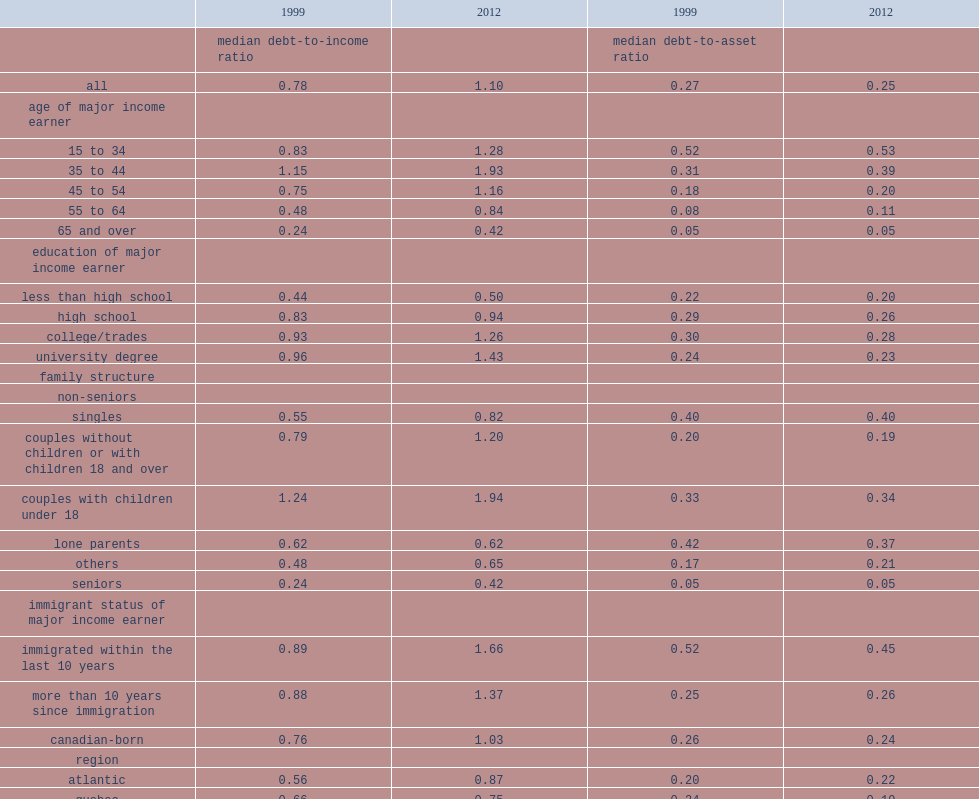What was the median debt-to-income ratio in 1999? 0.78. What was the median debt-to-income ratio in 2012? 1.1. How many times of the family income was the debt of the median family in 2012? 1.1. How much did the median debt-to-asset ratio amount to in 1999? 0.27. How much did the median debt-to-asset ratio amount to in 2012? 0.25. Which age group has the highest debt-to-income ratio? 35 to 44. What was the debt-to-income ratio among those aged 35 to 44 in 1999? 1.15. What was the debt-to-income ratio among those aged 35 to 44 in 2012? 1.93. What was the median ratio among families in the 65-and-over group in 1999? 0.24. What was the median ratio among families in the 65-and-over group in 2012? 0.42. What was the median debt-to-asset ratio for families whose major income earner was aged 35 to 44 in 1999? 0.31. What was the median debt-to-asset ratio for families whose major income earner was aged 35 to 44 in 2012? 0.39. What was the median debt-to-income ratio among mortgagees in 1999? 1.72. What was the median debt-to-income ratio among mortgagees in 2012? 2.46. What was the median debt-to-asset ratio of quebec in 1999? 0.24. What was the median debt-to-asset ratio of quebec in 2012? 0.19. 